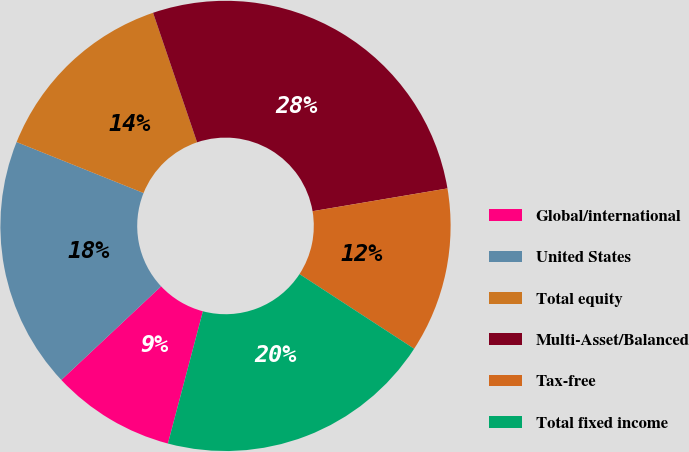Convert chart to OTSL. <chart><loc_0><loc_0><loc_500><loc_500><pie_chart><fcel>Global/international<fcel>United States<fcel>Total equity<fcel>Multi-Asset/Balanced<fcel>Tax-free<fcel>Total fixed income<nl><fcel>8.89%<fcel>18.07%<fcel>13.71%<fcel>27.55%<fcel>11.85%<fcel>19.93%<nl></chart> 